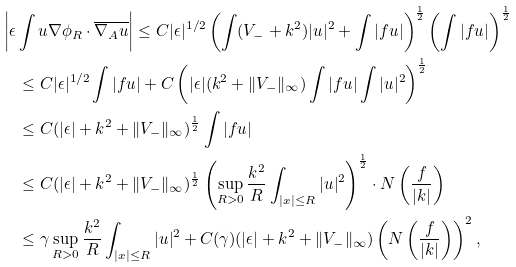<formula> <loc_0><loc_0><loc_500><loc_500>& \left | \epsilon \int u \nabla \phi _ { R } \cdot \overline { \nabla _ { A } u } \right | \leq C | \epsilon | ^ { 1 / 2 } \left ( \int ( V _ { - } + k ^ { 2 } ) | u | ^ { 2 } + \int | f u | \right ) ^ { \frac { 1 } { 2 } } \left ( \int | f u | \right ) ^ { \frac { 1 } { 2 } } \\ & \quad \leq C | \epsilon | ^ { 1 / 2 } \int | f u | + C \left ( | \epsilon | ( k ^ { 2 } + \| V _ { - } \| _ { \infty } ) \int | f u | \int | u | ^ { 2 } \right ) ^ { \frac { 1 } { 2 } } \\ & \quad \leq C ( | \epsilon | + k ^ { 2 } + \| V _ { - } \| _ { \infty } ) ^ { \frac { 1 } { 2 } } \int | f u | \\ & \quad \leq C ( | \epsilon | + k ^ { 2 } + \| V _ { - } \| _ { \infty } ) ^ { \frac { 1 } { 2 } } \left ( \sup _ { R > 0 } \frac { k ^ { 2 } } R \int _ { | x | \leq R } | u | ^ { 2 } \right ) ^ { \frac { 1 } { 2 } } \cdot N \left ( \frac { f } { | k | } \right ) \\ & \quad \leq \gamma \sup _ { R > 0 } \frac { k ^ { 2 } } R \int _ { | x | \leq R } | u | ^ { 2 } + C ( \gamma ) ( | \epsilon | + k ^ { 2 } + \| V _ { - } \| _ { \infty } ) \left ( N \left ( \frac { f } { | k | } \right ) \right ) ^ { 2 } ,</formula> 